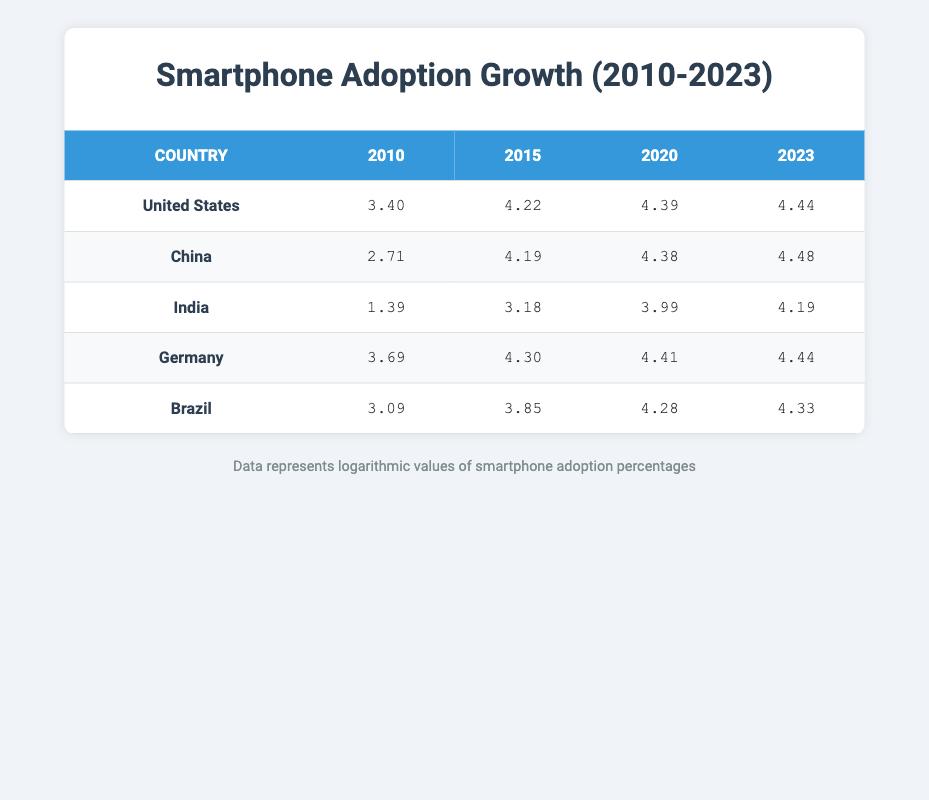What was the smartphone adoption percent in the United States in 2020? In the table under the "United States" row for the year 2020, the adoption percent is listed. According to the data, it shows 81.0 percent.
Answer: 81.0 Which country had the highest smartphone adoption percent in 2015? By looking at the 2015 column, it is clear that China had the highest adoption percent at 66.0, compared to the other countries listed (United States, India, Germany, Brazil).
Answer: China What is the difference in smartphone adoption percent between Brazil in 2015 and India in 2020? From the 2015 data for Brazil, the adoption percent is 47.0, and for India in 2020, it's 54.0. The difference is calculated as 54.0 - 47.0 = 7.0.
Answer: 7.0 Did the smartphone adoption percent in Germany increase from 2010 to 2023? By reviewing the table, Germany's adoption percent has increased from 40.0 in 2010 to 85.0 in 2023. Since both numbers are not equal and the latter is greater, the answer is yes.
Answer: Yes What is the average smartphone adoption percent for India from 2010 to 2023? The adoption percents for India are 4.0 (2010), 24.0 (2015), 54.0 (2020), and 66.0 (2023). First, total these values (4.0 + 24.0 + 54.0 + 66.0 = 148.0). Then, divide the sum by the number of years, which is 4 (148.0 / 4 = 37.0).
Answer: 37.0 Which country saw the most significant growth in smartphone adoption from 2010 to 2023? To determine the country with the most significant growth, we can compare the adoption percent in 2010 and 2023. United States: 30.0 to 85.0 (growth of 55.0), China: 15.0 to 88.0 (growth of 73.0), India: 4.0 to 66.0 (growth of 62.0), Germany: 40.0 to 85.0 (growth of 45.0), Brazil: 22.0 to 76.0 (growth of 54.0). China shows the greatest increase of 73.0 percent.
Answer: China 